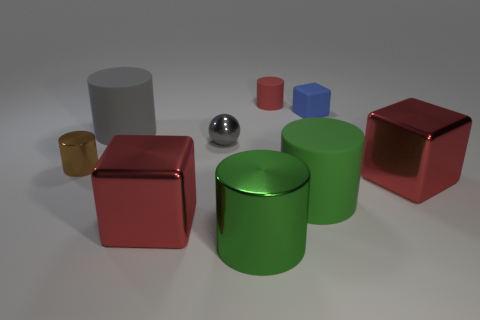Is the number of big red shiny blocks behind the large green metallic thing less than the number of metallic things that are on the left side of the small blue cube? Yes, the number of big red shiny blocks behind the large green metallic cylinder is indeed less. There are two big red shiny blocks, whereas there are three metallic objects (a small golden cup and two metallic cylinders) on the left side of the small blue cube. 